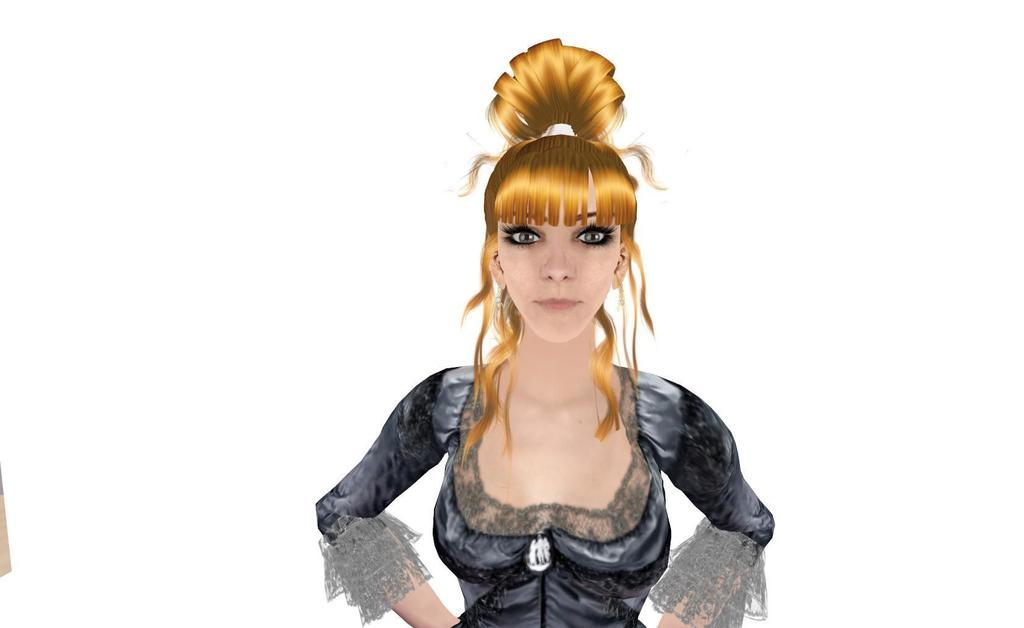What type of image is being described? The image is an animation. Can you describe the character in the animation? There is a woman in the image. What is the woman wearing? The woman is wearing a black dress. Can you see the ocean in the background of the animation? There is no ocean visible in the image; it is an animation featuring a woman in a black dress. Is there a cow present in the animation? There is no cow present in the animation; it only features a woman wearing a black dress. 